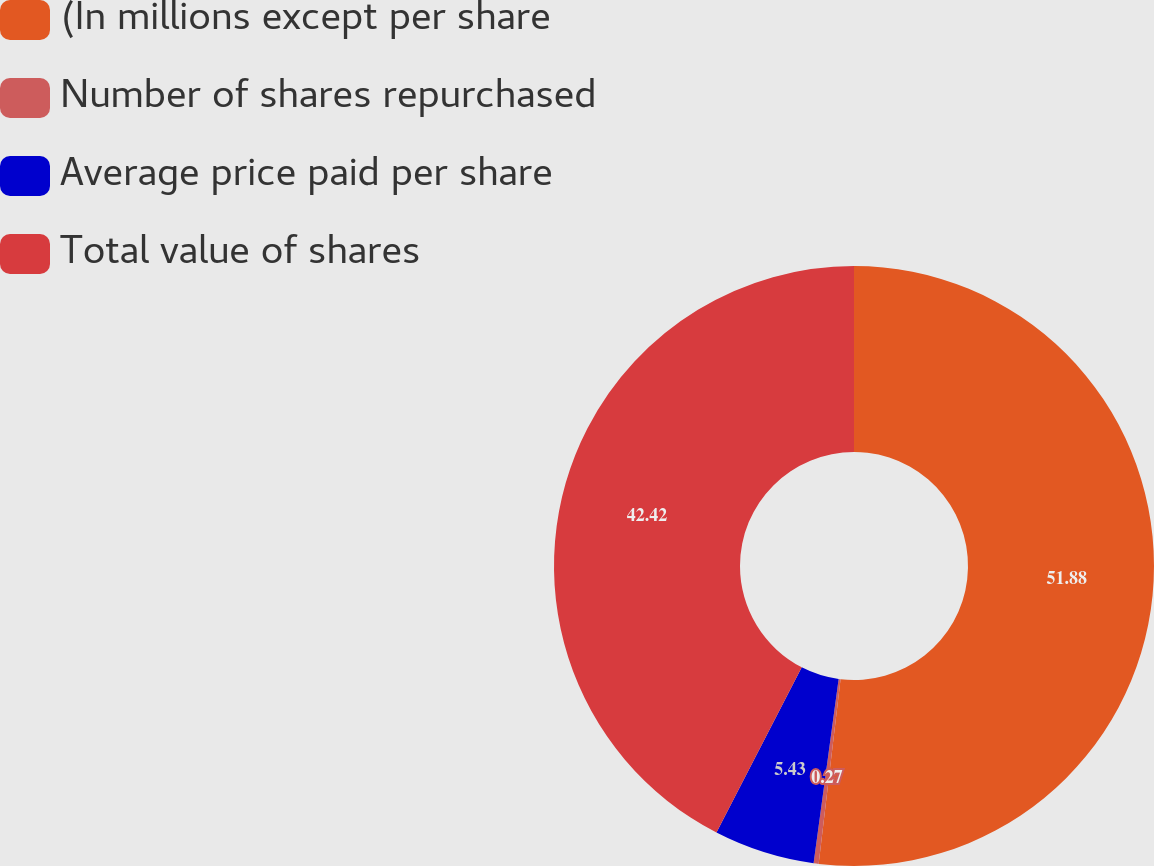Convert chart to OTSL. <chart><loc_0><loc_0><loc_500><loc_500><pie_chart><fcel>(In millions except per share<fcel>Number of shares repurchased<fcel>Average price paid per share<fcel>Total value of shares<nl><fcel>51.88%<fcel>0.27%<fcel>5.43%<fcel>42.42%<nl></chart> 